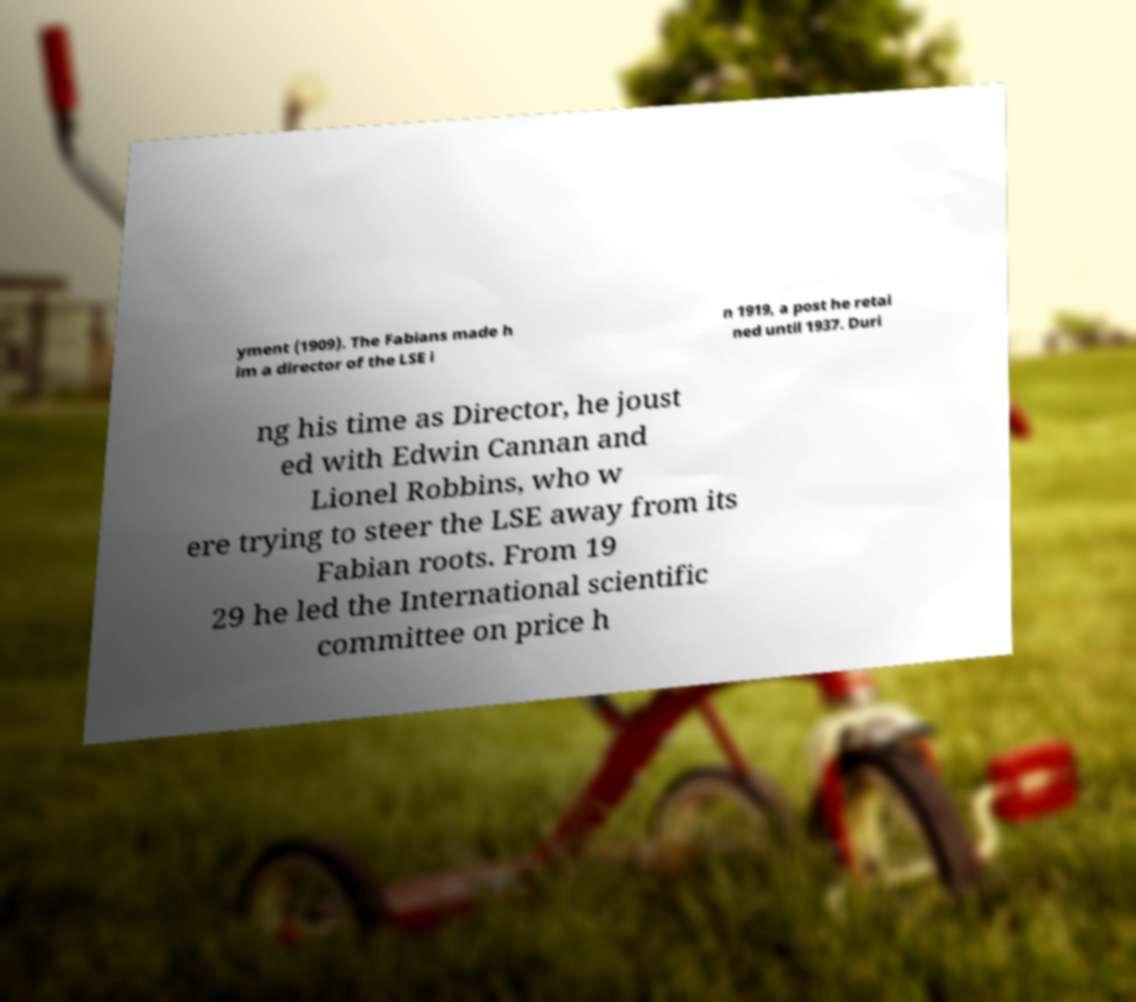Could you assist in decoding the text presented in this image and type it out clearly? yment (1909). The Fabians made h im a director of the LSE i n 1919, a post he retai ned until 1937. Duri ng his time as Director, he joust ed with Edwin Cannan and Lionel Robbins, who w ere trying to steer the LSE away from its Fabian roots. From 19 29 he led the International scientific committee on price h 